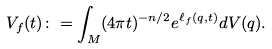<formula> <loc_0><loc_0><loc_500><loc_500>V _ { f } ( t ) \colon = \int _ { M } ( 4 \pi t ) ^ { - n / 2 } e ^ { \ell _ { f } ( q , t ) } d V ( q ) .</formula> 